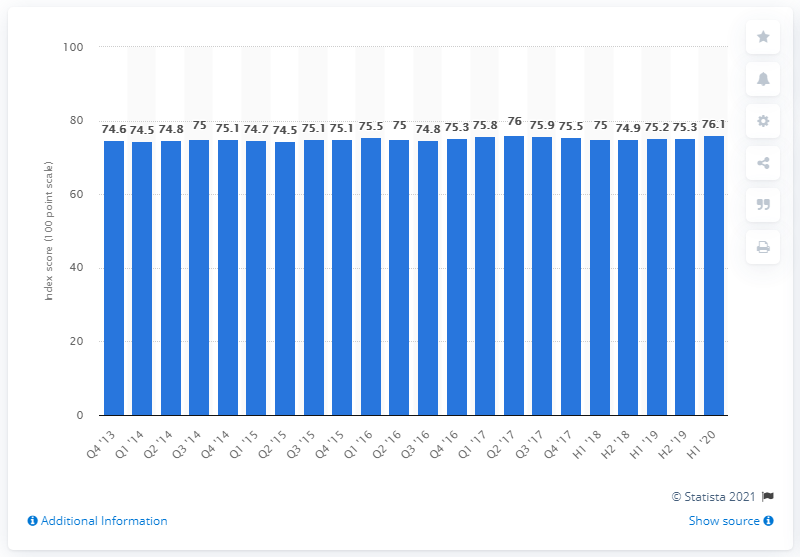Identify some key points in this picture. The satisfaction level of customers with e-government websites and services during the first half of 2020 was 76.1%. 